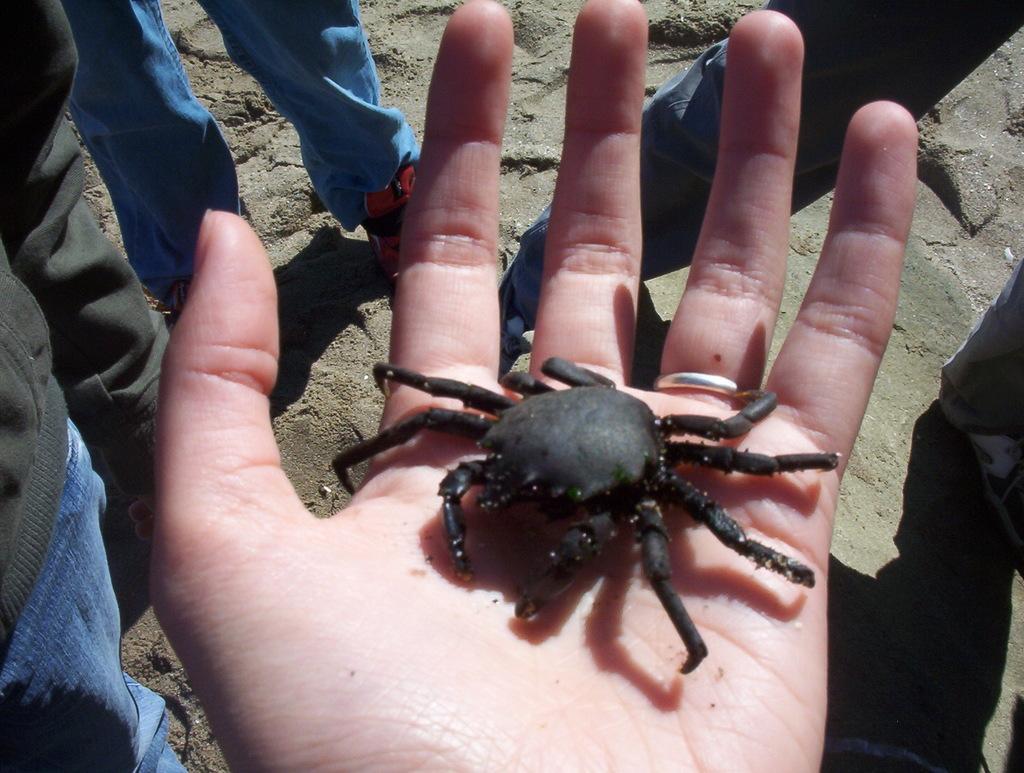In one or two sentences, can you explain what this image depicts? In the picture we can see a hand palm on it we can see a crab which is black in color and around the hand we can see some people are standing on the sand surface. 